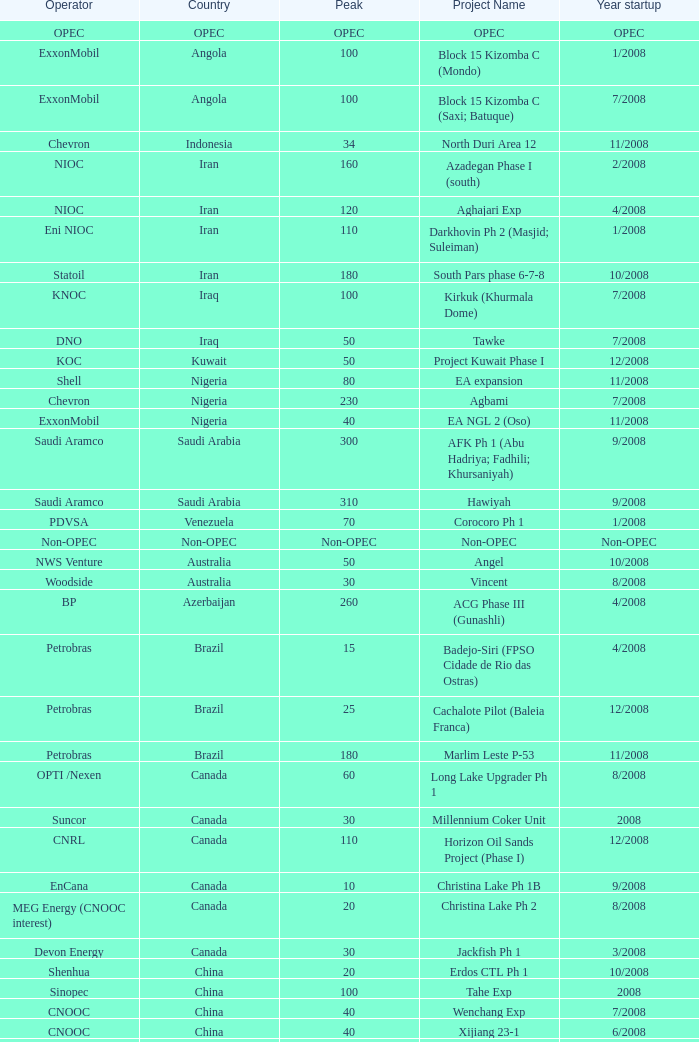What is the Peak with a Project Name that is talakan ph 1? 60.0. 